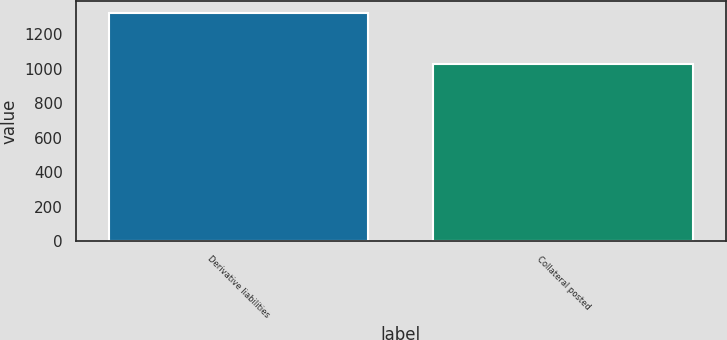<chart> <loc_0><loc_0><loc_500><loc_500><bar_chart><fcel>Derivative liabilities<fcel>Collateral posted<nl><fcel>1324<fcel>1026<nl></chart> 